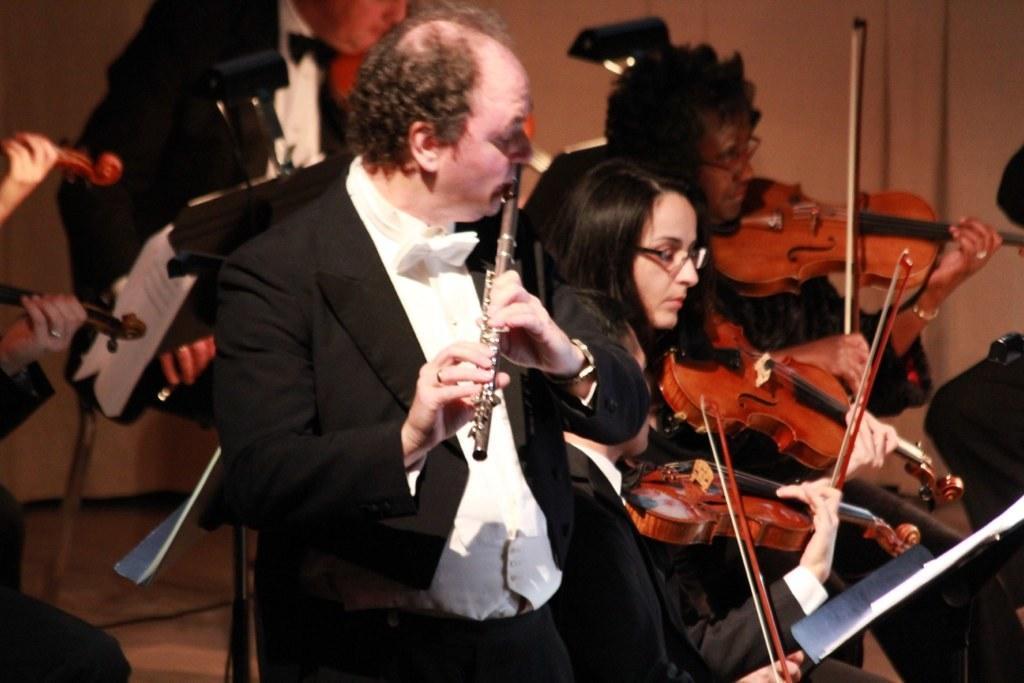Please provide a concise description of this image. In this picture there are so many people are playing musical instruments and few of them are holding a paper. 